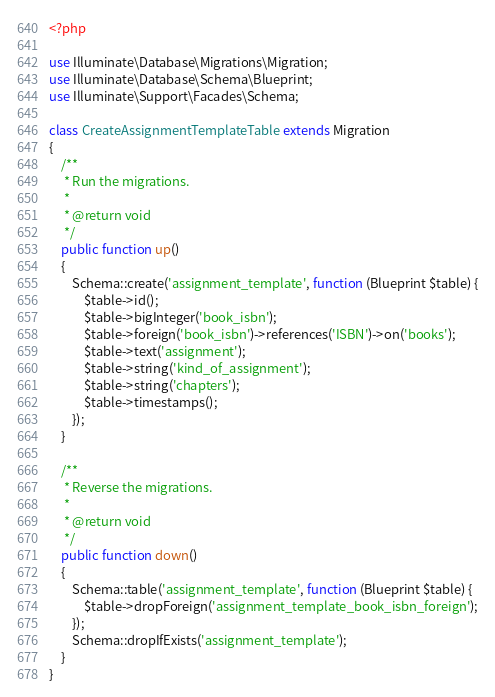<code> <loc_0><loc_0><loc_500><loc_500><_PHP_><?php

use Illuminate\Database\Migrations\Migration;
use Illuminate\Database\Schema\Blueprint;
use Illuminate\Support\Facades\Schema;

class CreateAssignmentTemplateTable extends Migration
{
    /**
     * Run the migrations.
     *
     * @return void
     */
    public function up()
    {
        Schema::create('assignment_template', function (Blueprint $table) {
            $table->id();
            $table->bigInteger('book_isbn');
            $table->foreign('book_isbn')->references('ISBN')->on('books');
            $table->text('assignment');
            $table->string('kind_of_assignment');
            $table->string('chapters');
            $table->timestamps();
        });
    }

    /**
     * Reverse the migrations.
     *
     * @return void
     */
    public function down()
    {
        Schema::table('assignment_template', function (Blueprint $table) {
            $table->dropForeign('assignment_template_book_isbn_foreign');
        });
        Schema::dropIfExists('assignment_template');
    }
}
</code> 